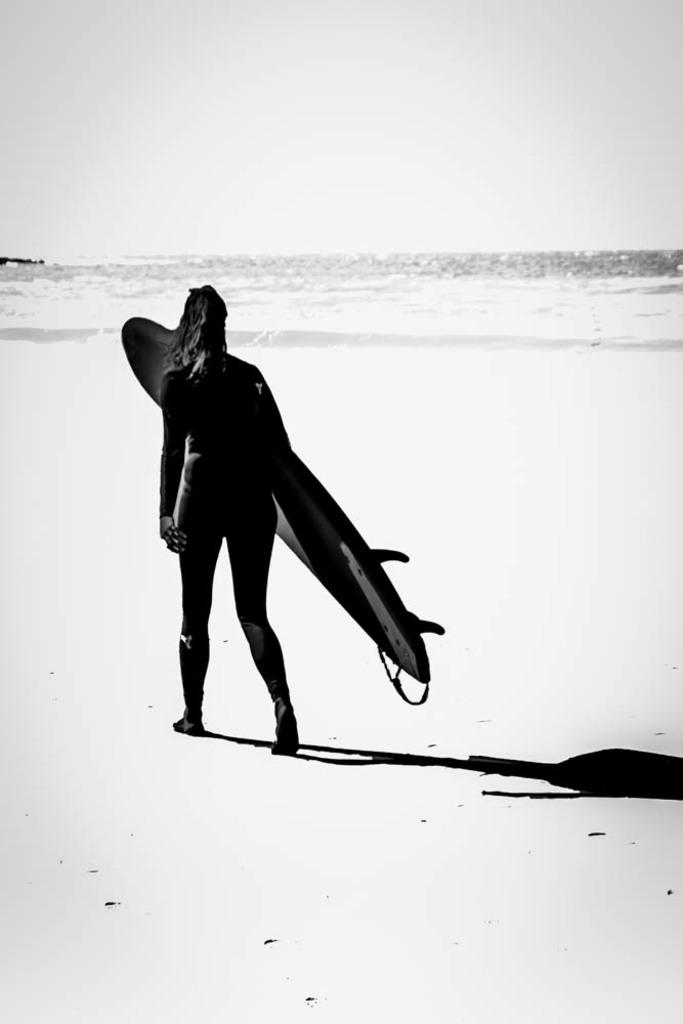Who is the main subject in the image? There is a woman in the image. What is the woman carrying? The woman is carrying a surfboard. What is the woman doing in the image? The woman is walking. What can be seen in the background of the image? There is water visible in the background of the image. What is the color scheme of the image? The image is in black and white. Can you tell me where the donkey is located in the image? There is no donkey present in the image. What type of locket is the woman wearing in the image? The image is in black and white, and there is no indication of any jewelry, including a locket, being worn by the woman. 